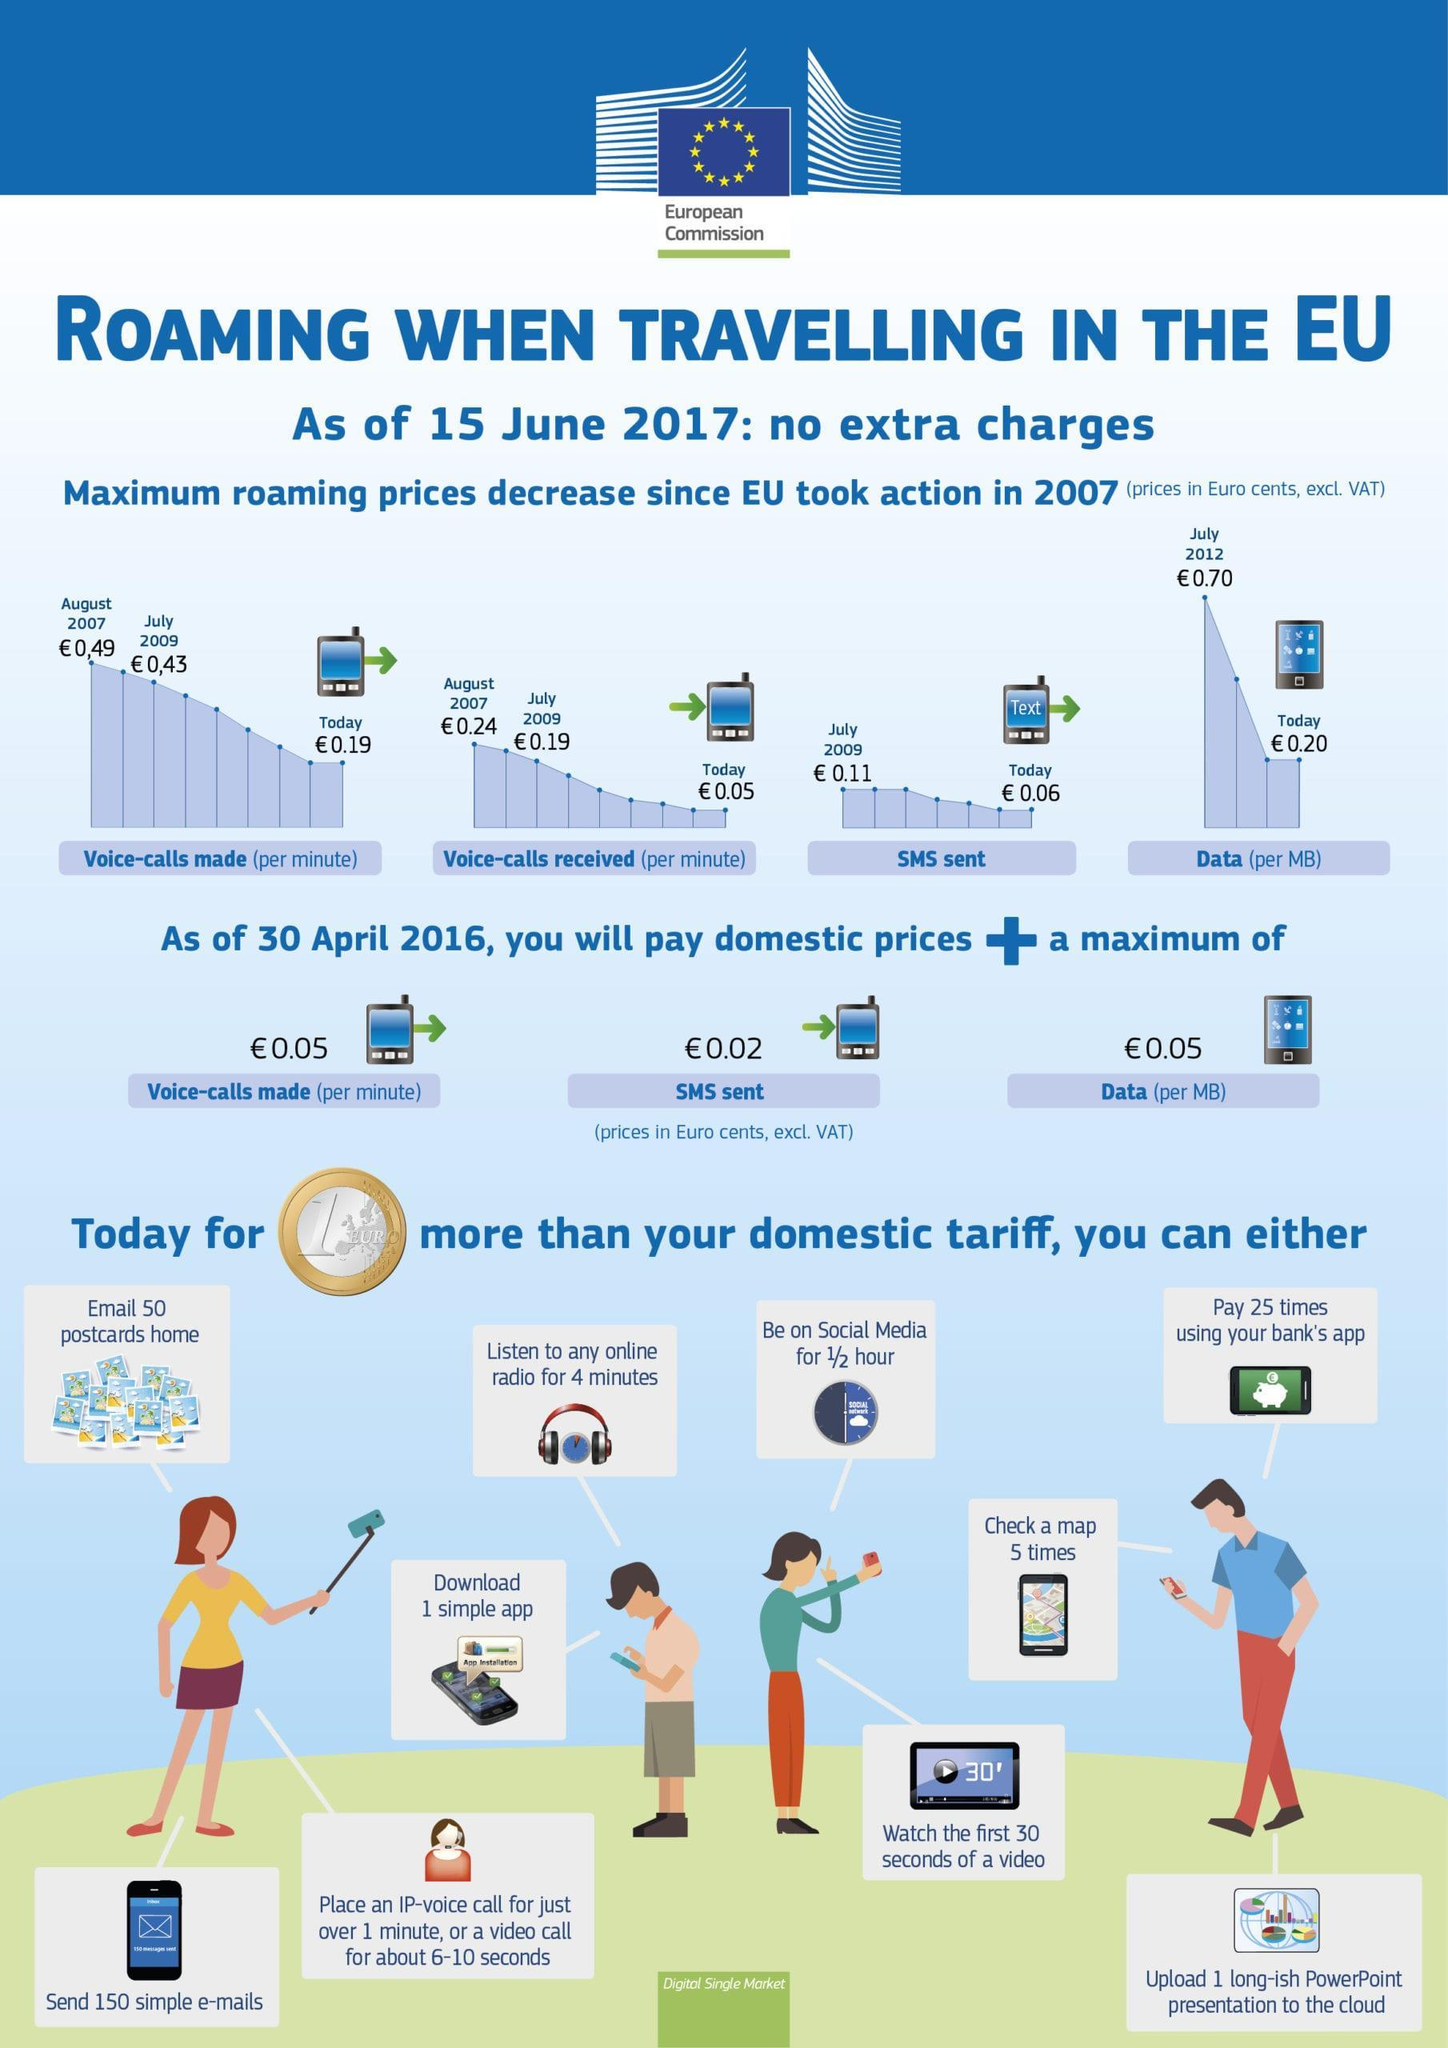How many cents did the roaming data cost per MB decrease from July 2012 to today
Answer the question with a short phrase. 50 As of 30 April 2016, how many cents additional would need to be paid for sms sent 0.02 How many minutes can we be on social media for 1 euro more than domestic tariff 30 How many apps can be downloaded for 1 euro more than domestic tariff 1 simple app What is the amount written in the coin 1 euro How long can we listen to online radio for 1 euro more than domestic tariff 4 minutes 